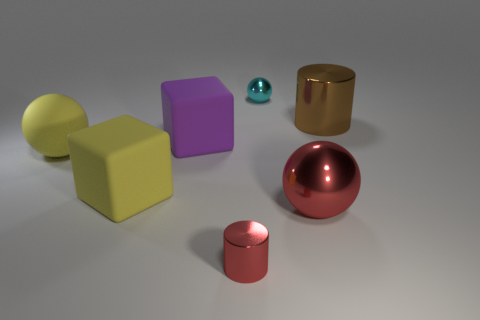Add 1 big red rubber cylinders. How many objects exist? 8 Subtract all spheres. How many objects are left? 4 Subtract all purple objects. Subtract all big yellow objects. How many objects are left? 4 Add 5 matte blocks. How many matte blocks are left? 7 Add 5 big yellow shiny objects. How many big yellow shiny objects exist? 5 Subtract 1 brown cylinders. How many objects are left? 6 